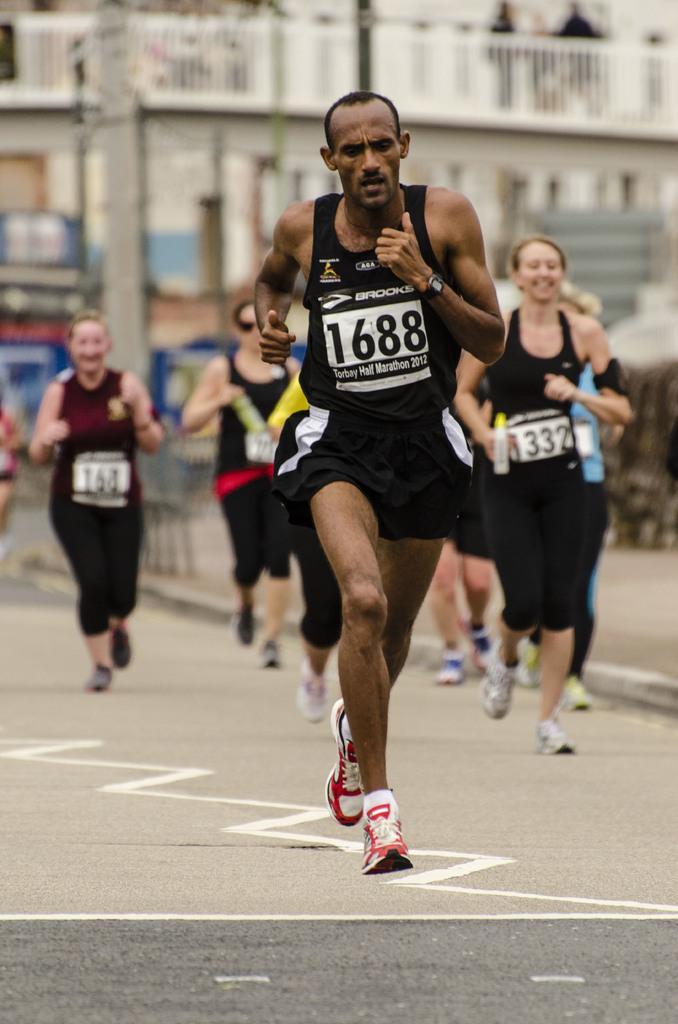In one or two sentences, can you explain what this image depicts? In this image we can see some group of persons wearing sports dress running on road and in the background of the image there are some houses. 